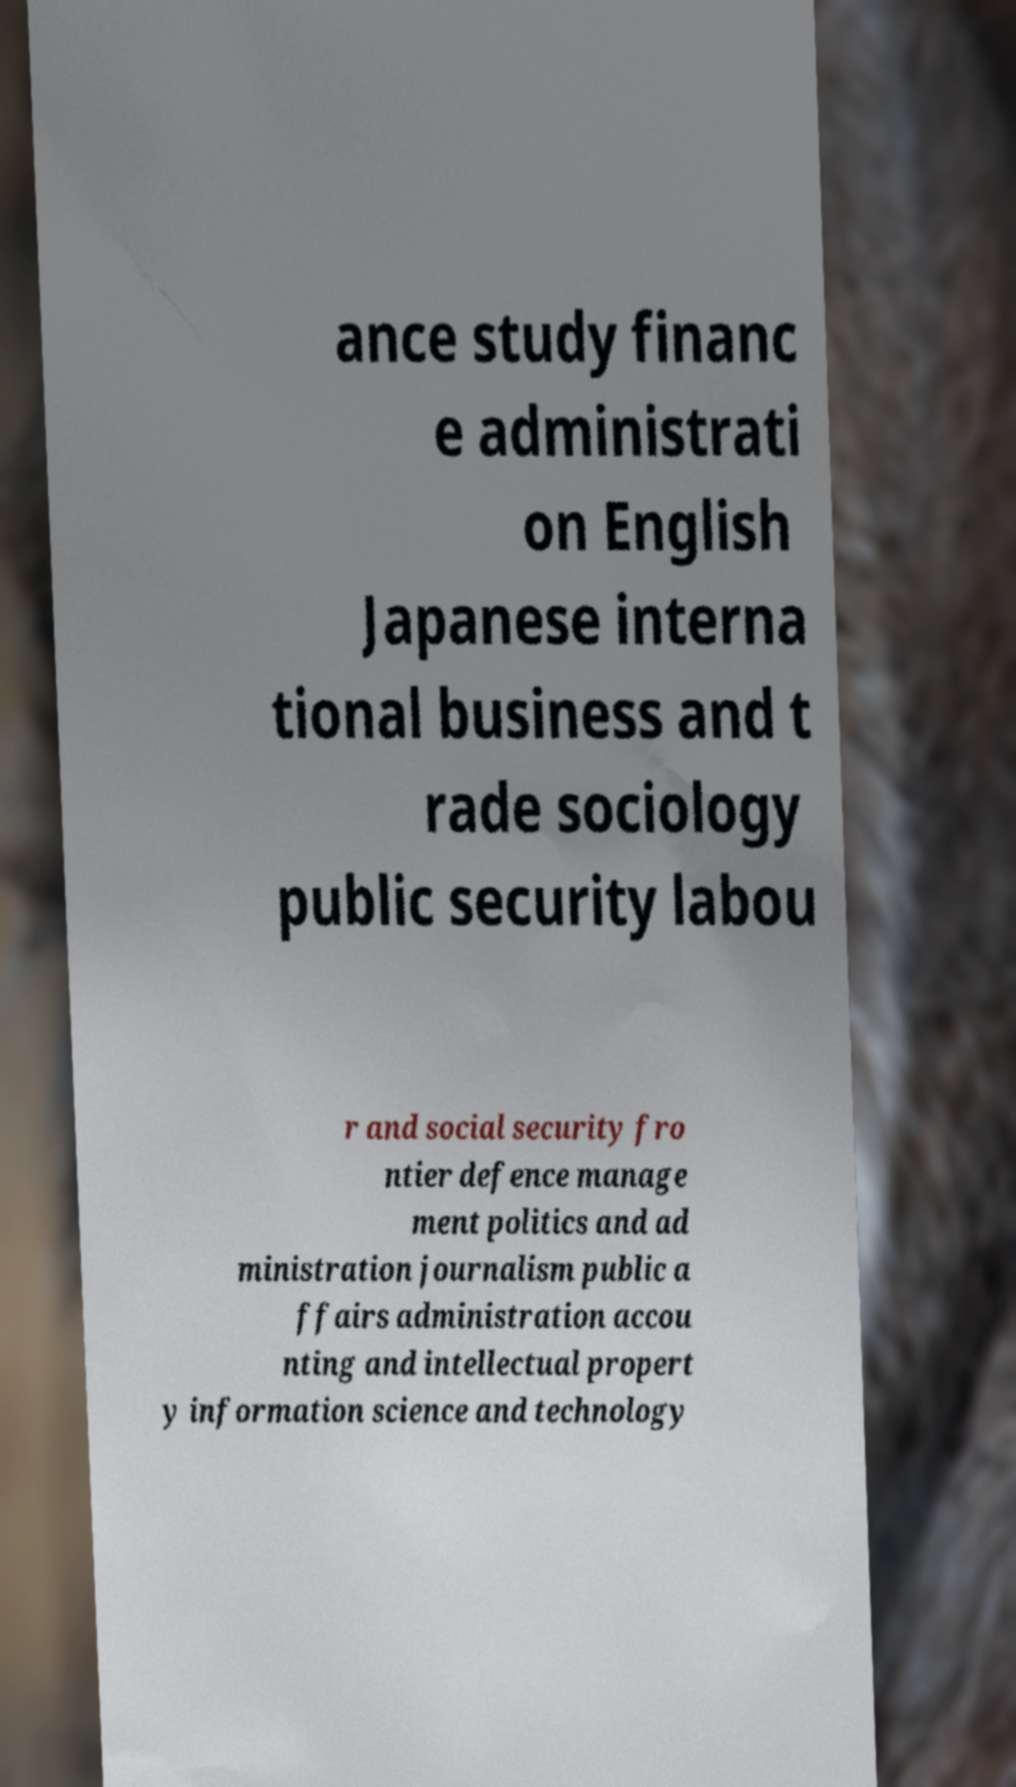Please identify and transcribe the text found in this image. ance study financ e administrati on English Japanese interna tional business and t rade sociology public security labou r and social security fro ntier defence manage ment politics and ad ministration journalism public a ffairs administration accou nting and intellectual propert y information science and technology 